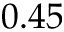<formula> <loc_0><loc_0><loc_500><loc_500>0 . 4 5</formula> 